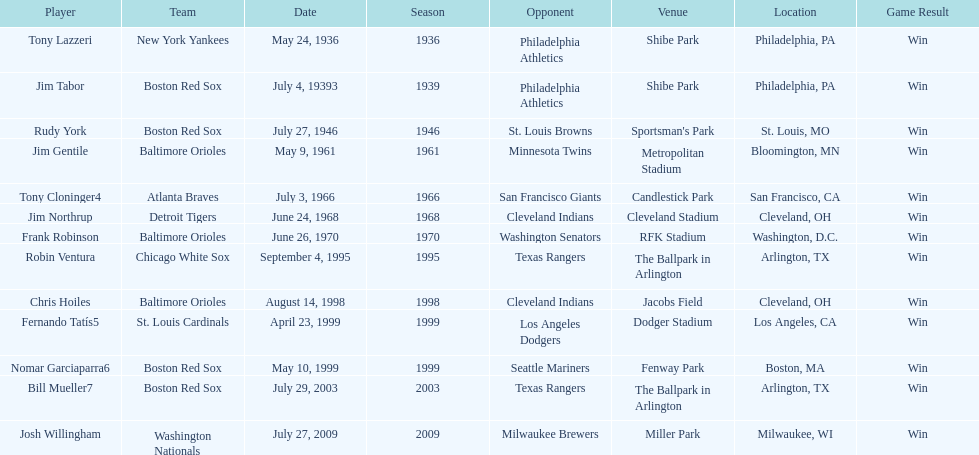What was the name of the player who accomplished this in 1999 but played for the boston red sox? Nomar Garciaparra. 